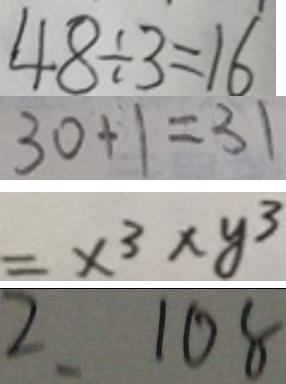Convert formula to latex. <formula><loc_0><loc_0><loc_500><loc_500>4 8 \div 3 = 1 6 
 3 0 + 1 = 3 1 
 = x ^ { 3 } \times y ^ { 3 } 
 2 . 1 0 8</formula> 